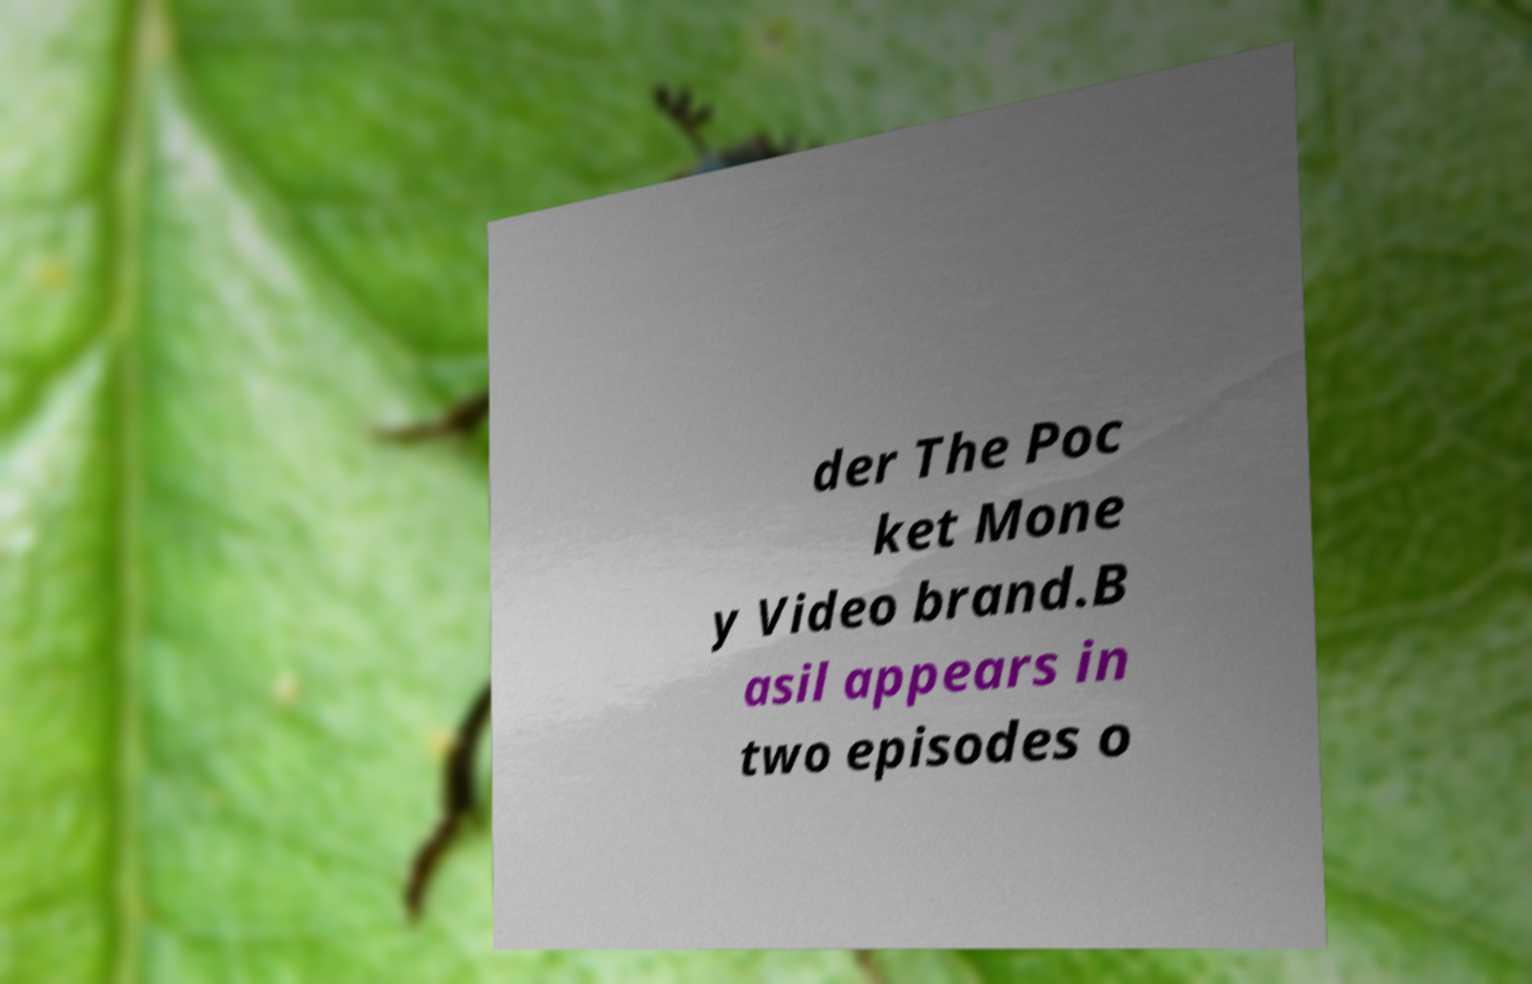For documentation purposes, I need the text within this image transcribed. Could you provide that? der The Poc ket Mone y Video brand.B asil appears in two episodes o 